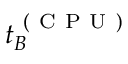Convert formula to latex. <formula><loc_0><loc_0><loc_500><loc_500>t _ { B } ^ { ( C P U ) }</formula> 